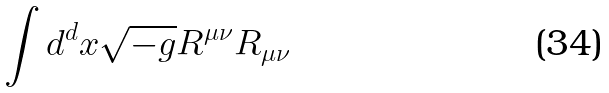<formula> <loc_0><loc_0><loc_500><loc_500>\int d ^ { d } x \sqrt { - g } R ^ { \mu \nu } R _ { \mu \nu }</formula> 